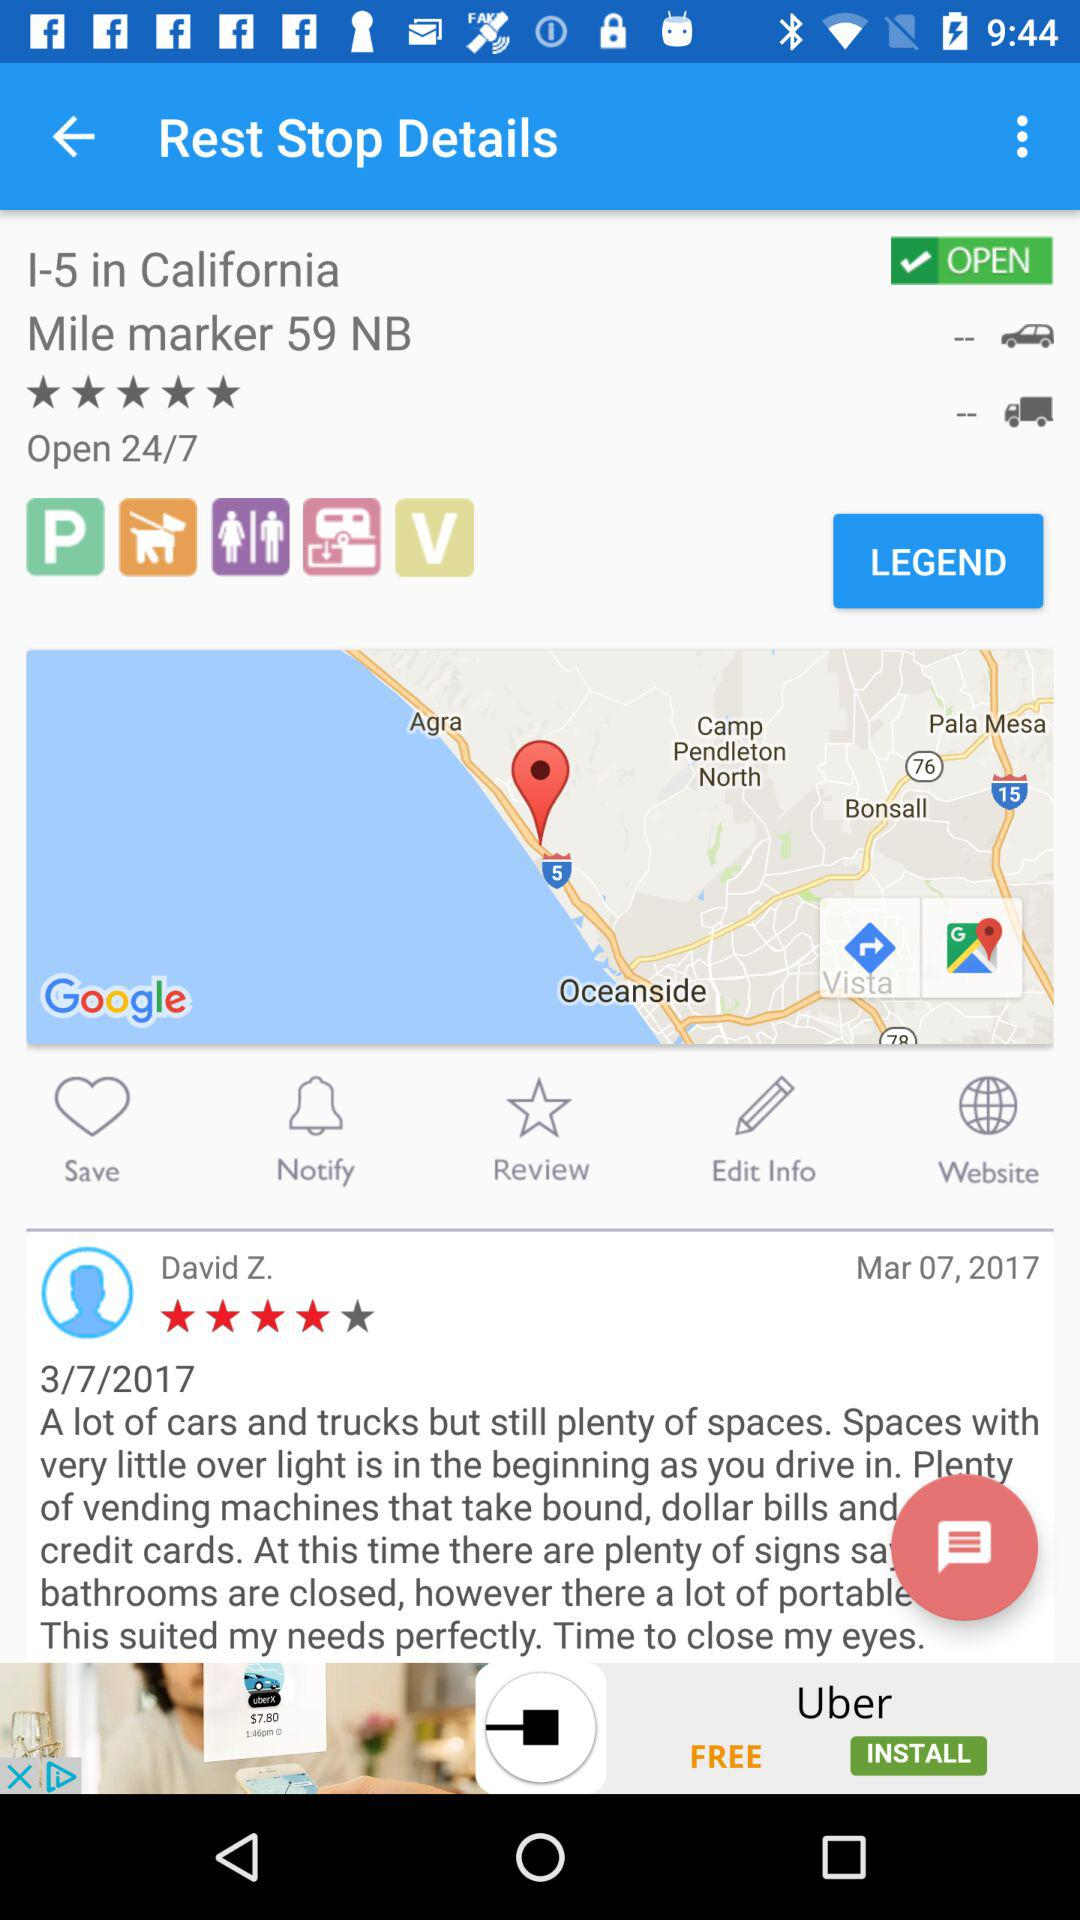What is the user name? The user name is "David Z". 